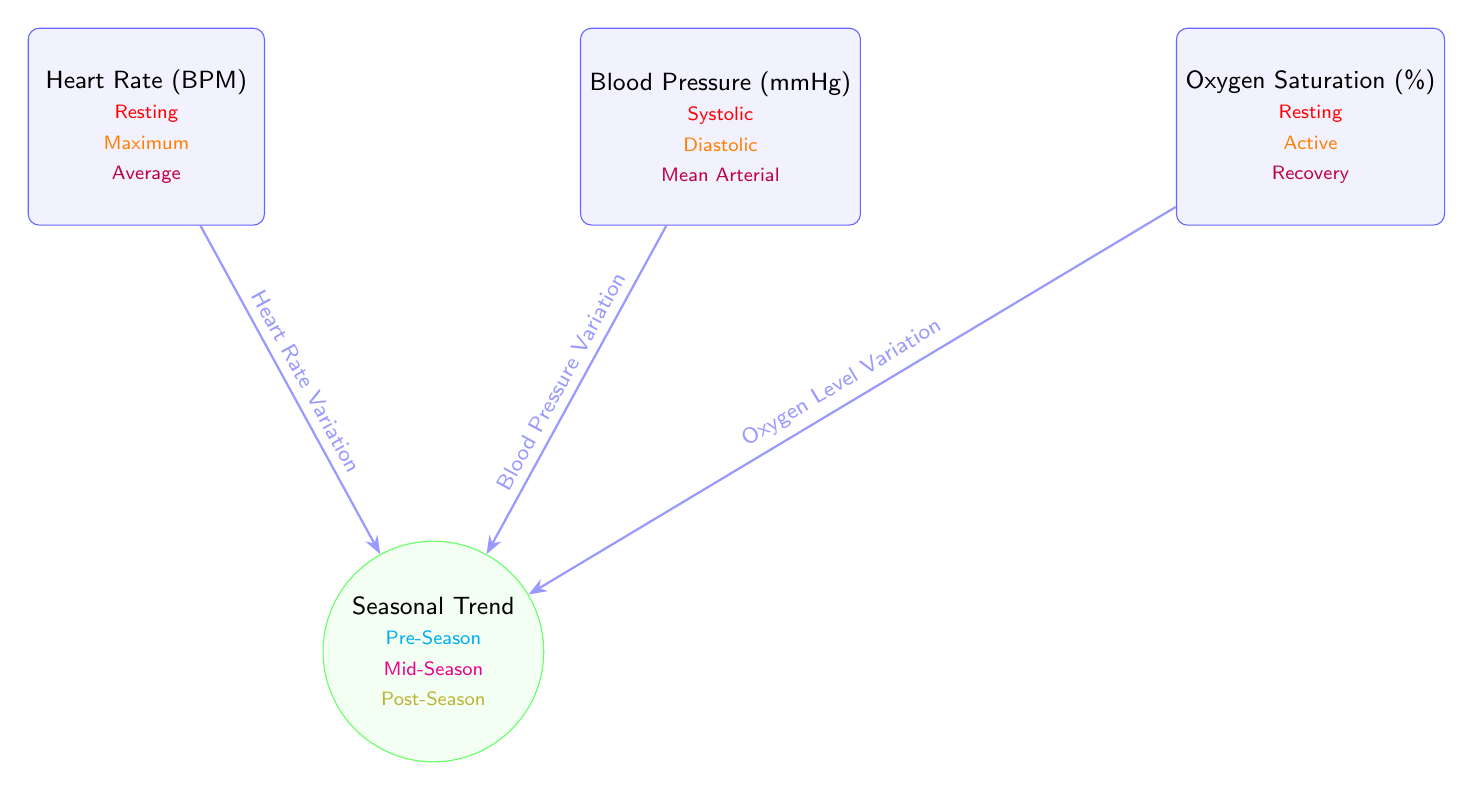What's the maximum heart rate depicted in the diagram? The heart rate section includes three categories: Resting, Maximum, and Average. The maximum heart rate is labeled under the Maximum category, which is visually highlighted with the color orange.
Answer: Maximum How many different cardiovascular metrics are displayed in the diagram? The diagram presents three main cardiovascular metrics: Heart Rate, Blood Pressure, and Oxygen Saturation. Count the distinct categories listed to find the total number.
Answer: Three What does the blue arrow connecting the Heart Rate and Seasonal Trend signify? The blue arrow indicates the relationship or influence between Heart Rate and Seasonal Trend, specifically labeled as "Heart Rate Variation." This signifies that heart rate changes over different stages of the season.
Answer: Heart Rate Variation Which vignettes within the Oxygen Saturation section relate to activity levels? The Oxygen Saturation section lists Resting, Active, and Recovery levels. The relevant vignette that indicates activity levels is noted as "Active."
Answer: Active What color denotes the Mid-Season category in the Seasonal Trend node? The Mid-Season category is visually represented in the diagram with the color magenta. This color coding provides a clear distinction from the other seasonal categories.
Answer: Magenta Which cardiovascular metric has a value labeled as "Mean Arterial" pressure? The Blood Pressure data node lists various pressures, and the value labeled "Mean Arterial" is specifically located under the Blood Pressure category. This indicates a combination of systolic and diastolic pressures averaged over a period.
Answer: Mean Arterial Which seasonal category comes first according to the diagram? The seasonal categories are Pre-Season, Mid-Season, and Post-Season. The first category that appears in the Seasonal Trend node is Pre-Season, as denoted by its positioning and color coding.
Answer: Pre-Season How many types of blood pressure are indicated in the diagram? The Blood Pressure data node illustrates three distinct types: Systolic, Diastolic, and Mean Arterial. You can enumerate from the specified labels to reach this number.
Answer: Three 